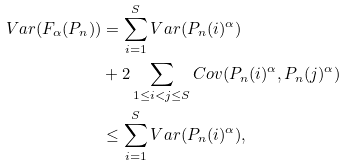Convert formula to latex. <formula><loc_0><loc_0><loc_500><loc_500>V a r ( F _ { \alpha } ( P _ { n } ) ) & = \sum _ { i = 1 } ^ { S } V a r ( P _ { n } ( i ) ^ { \alpha } ) \\ & + 2 \sum _ { 1 \leq i < j \leq S } C o v ( P _ { n } ( i ) ^ { \alpha } , P _ { n } ( j ) ^ { \alpha } ) \\ & \leq \sum _ { i = 1 } ^ { S } V a r ( P _ { n } ( i ) ^ { \alpha } ) ,</formula> 